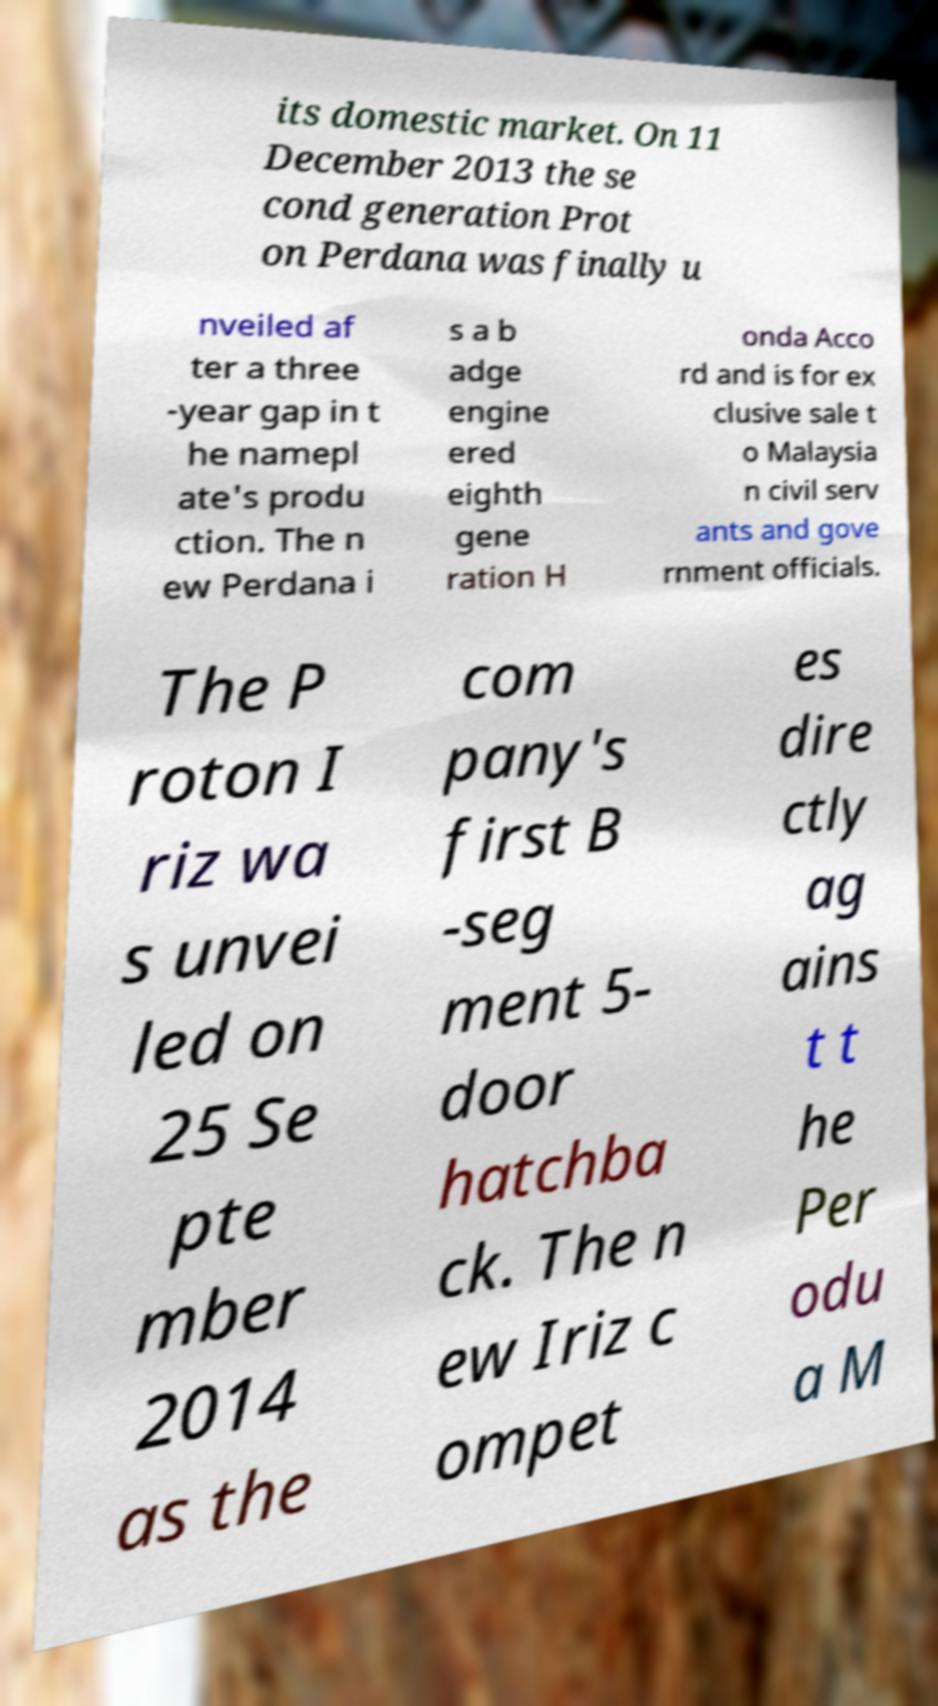Can you read and provide the text displayed in the image?This photo seems to have some interesting text. Can you extract and type it out for me? its domestic market. On 11 December 2013 the se cond generation Prot on Perdana was finally u nveiled af ter a three -year gap in t he namepl ate's produ ction. The n ew Perdana i s a b adge engine ered eighth gene ration H onda Acco rd and is for ex clusive sale t o Malaysia n civil serv ants and gove rnment officials. The P roton I riz wa s unvei led on 25 Se pte mber 2014 as the com pany's first B -seg ment 5- door hatchba ck. The n ew Iriz c ompet es dire ctly ag ains t t he Per odu a M 